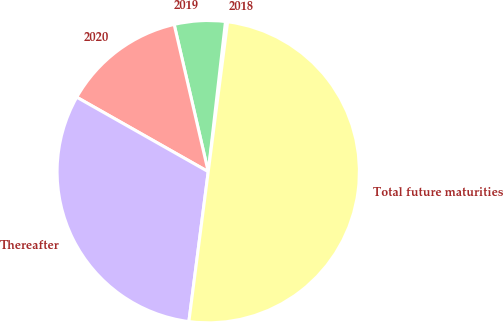Convert chart to OTSL. <chart><loc_0><loc_0><loc_500><loc_500><pie_chart><fcel>2018<fcel>2019<fcel>2020<fcel>Thereafter<fcel>Total future maturities<nl><fcel>0.23%<fcel>5.44%<fcel>13.18%<fcel>31.16%<fcel>50.0%<nl></chart> 